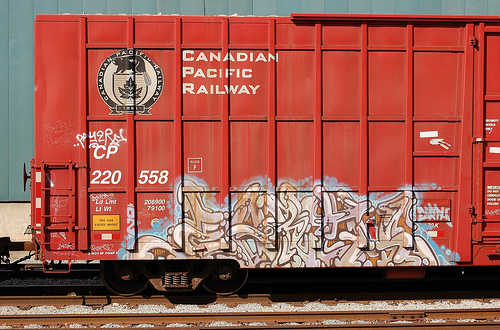<image>
Is there a fence behind the wood? No. The fence is not behind the wood. From this viewpoint, the fence appears to be positioned elsewhere in the scene. 